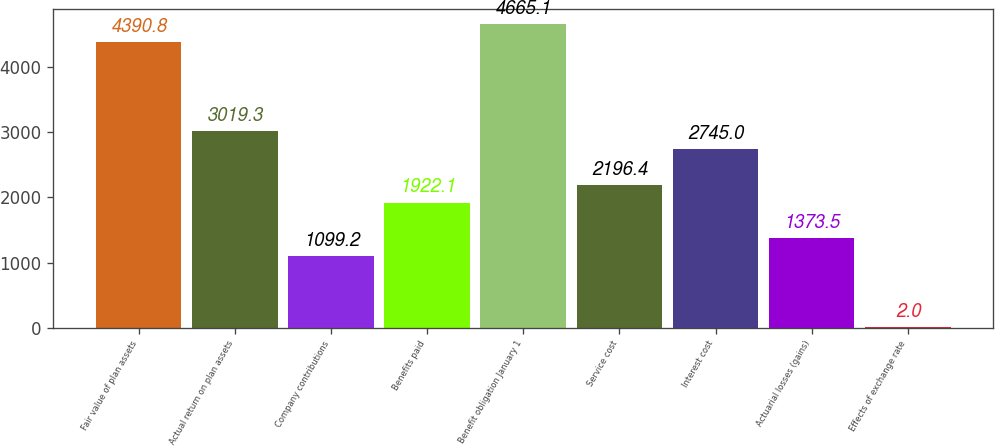<chart> <loc_0><loc_0><loc_500><loc_500><bar_chart><fcel>Fair value of plan assets<fcel>Actual return on plan assets<fcel>Company contributions<fcel>Benefits paid<fcel>Benefit obligation January 1<fcel>Service cost<fcel>Interest cost<fcel>Actuarial losses (gains)<fcel>Effects of exchange rate<nl><fcel>4390.8<fcel>3019.3<fcel>1099.2<fcel>1922.1<fcel>4665.1<fcel>2196.4<fcel>2745<fcel>1373.5<fcel>2<nl></chart> 